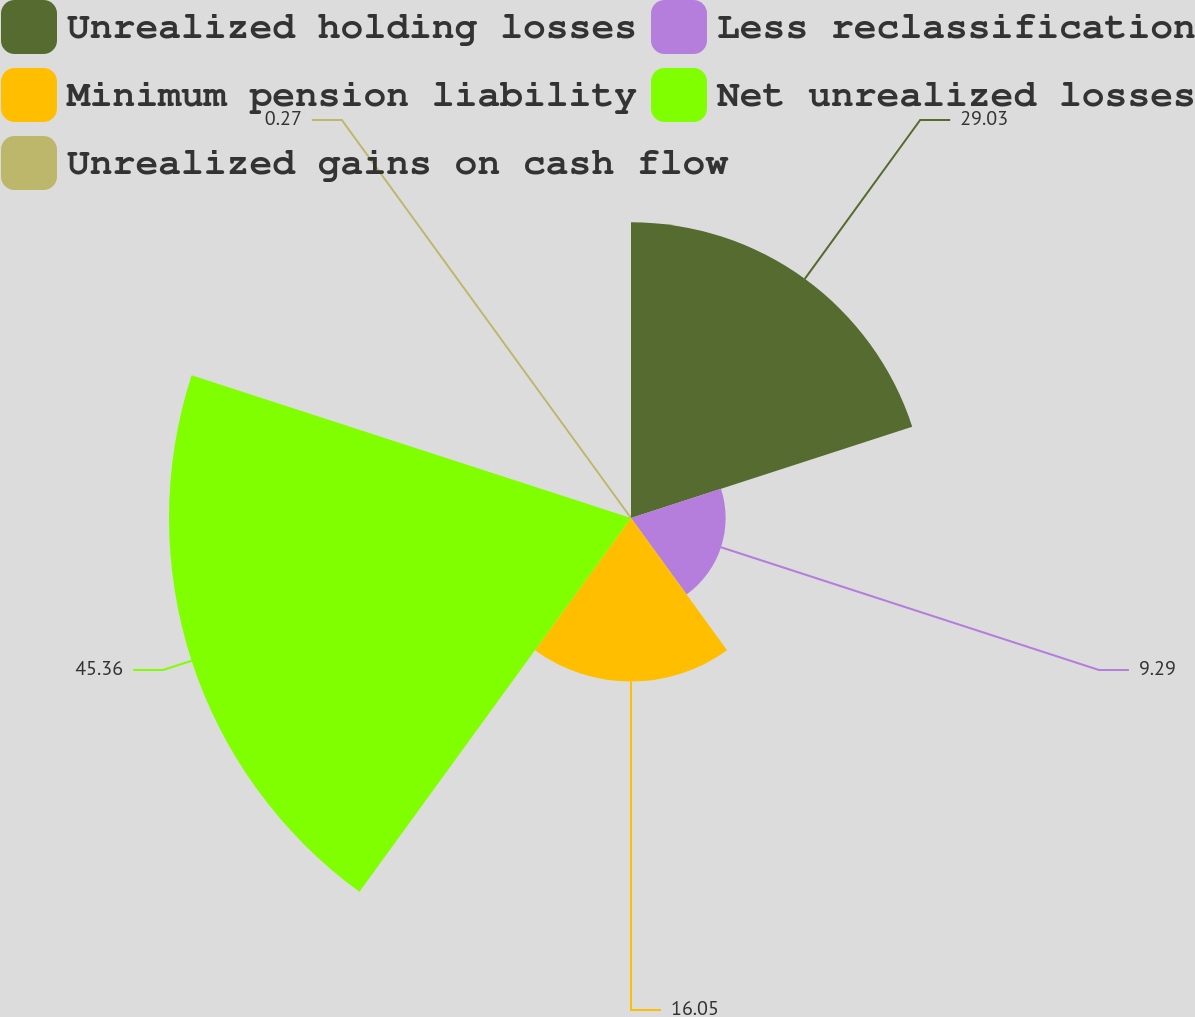Convert chart. <chart><loc_0><loc_0><loc_500><loc_500><pie_chart><fcel>Unrealized holding losses<fcel>Less reclassification<fcel>Minimum pension liability<fcel>Net unrealized losses<fcel>Unrealized gains on cash flow<nl><fcel>29.03%<fcel>9.29%<fcel>16.05%<fcel>45.36%<fcel>0.27%<nl></chart> 